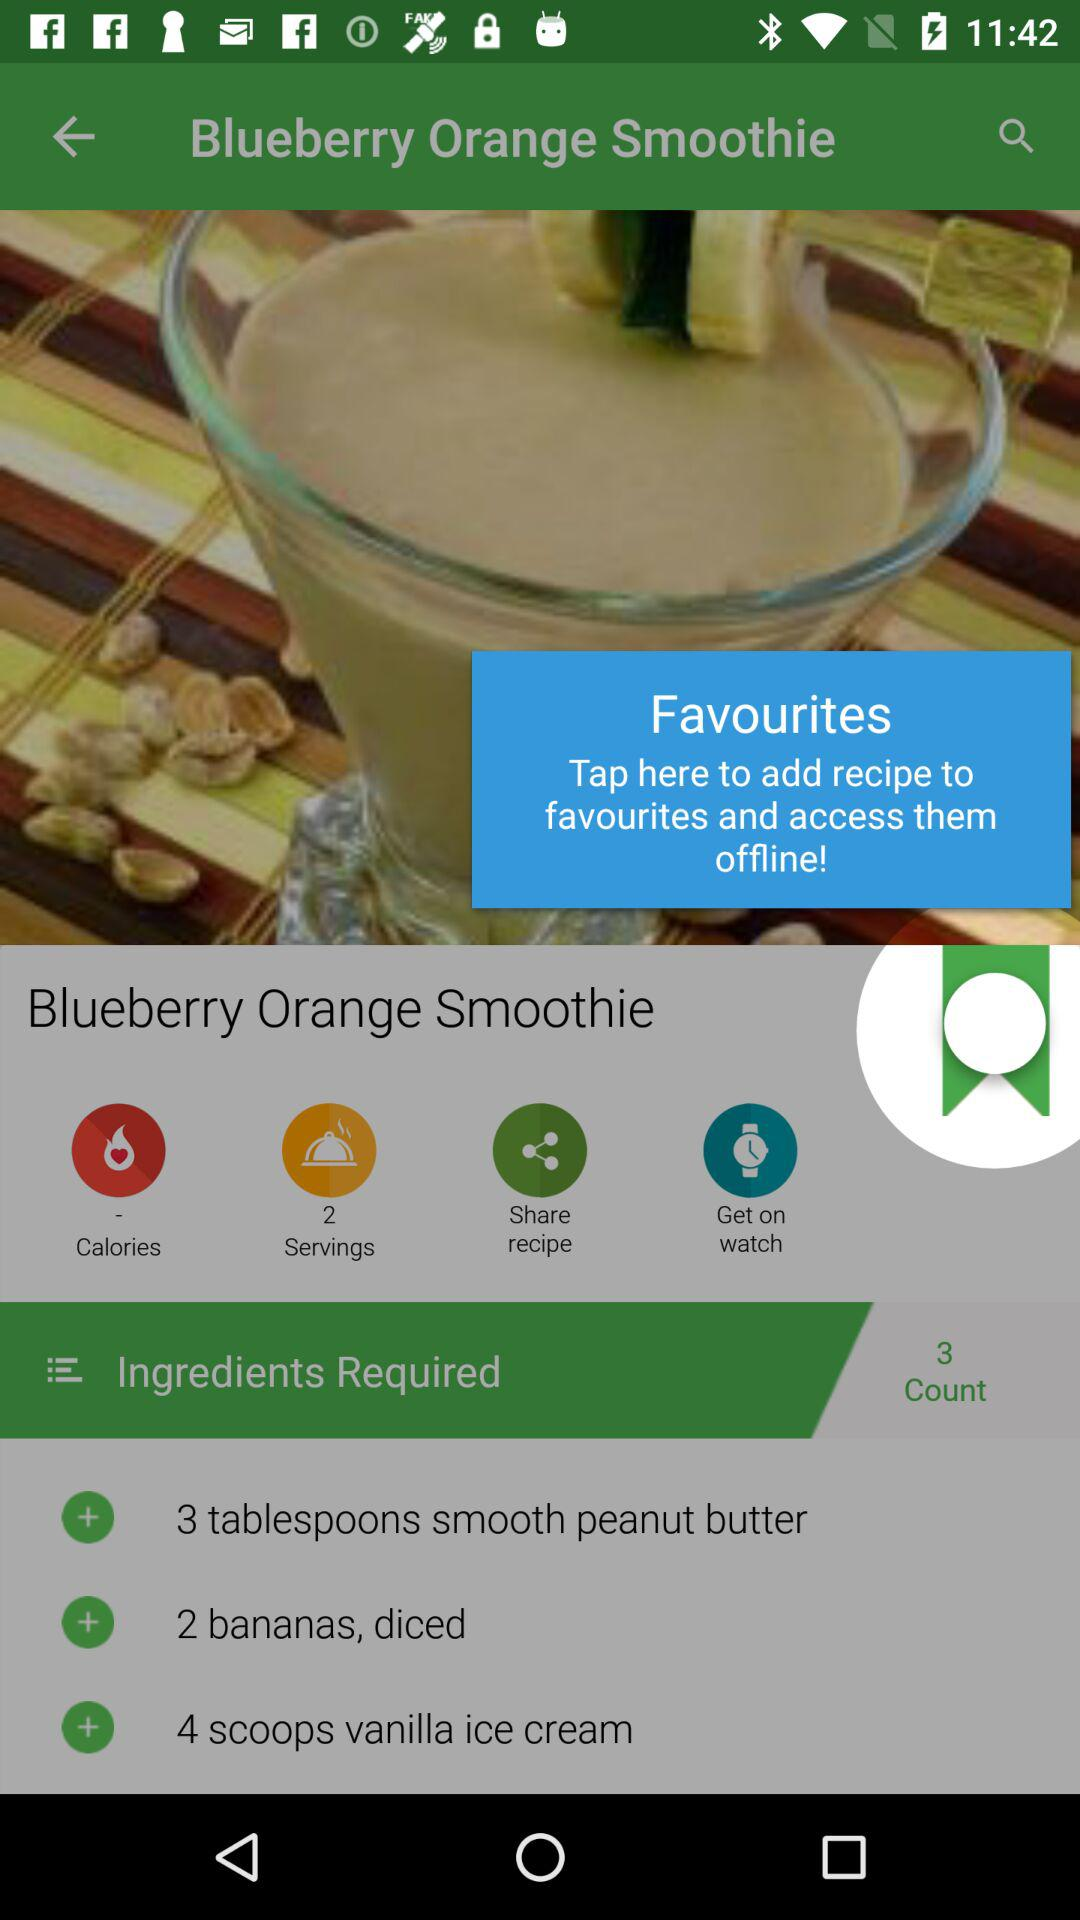What is the count of the required ingredient? The count of the required ingredient is 3. 